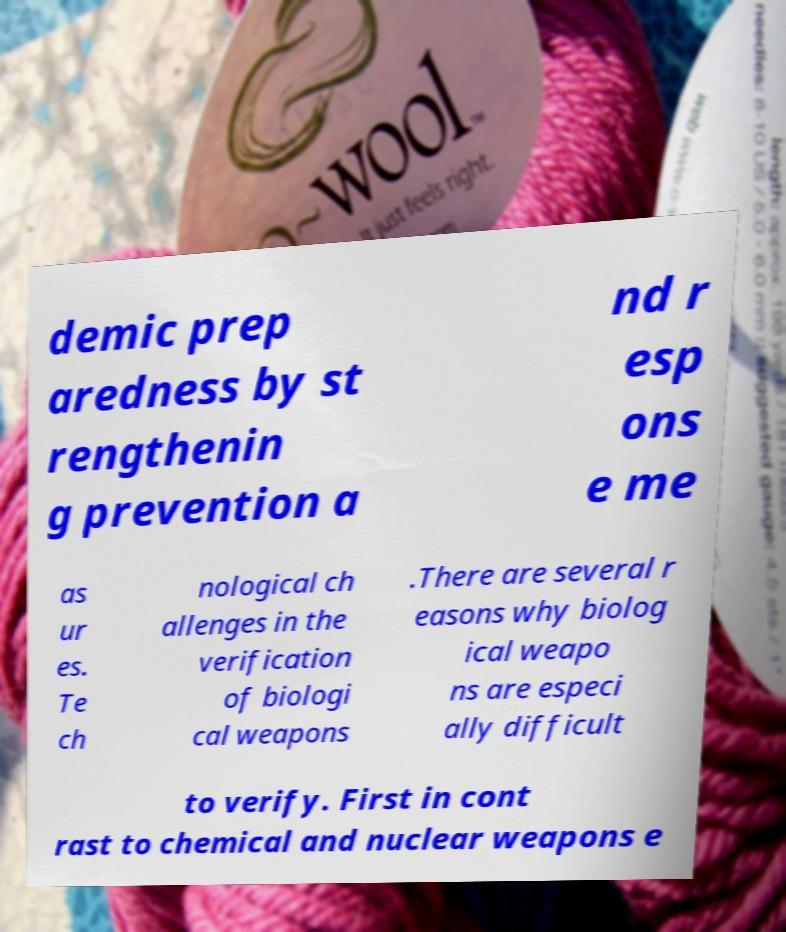There's text embedded in this image that I need extracted. Can you transcribe it verbatim? demic prep aredness by st rengthenin g prevention a nd r esp ons e me as ur es. Te ch nological ch allenges in the verification of biologi cal weapons .There are several r easons why biolog ical weapo ns are especi ally difficult to verify. First in cont rast to chemical and nuclear weapons e 